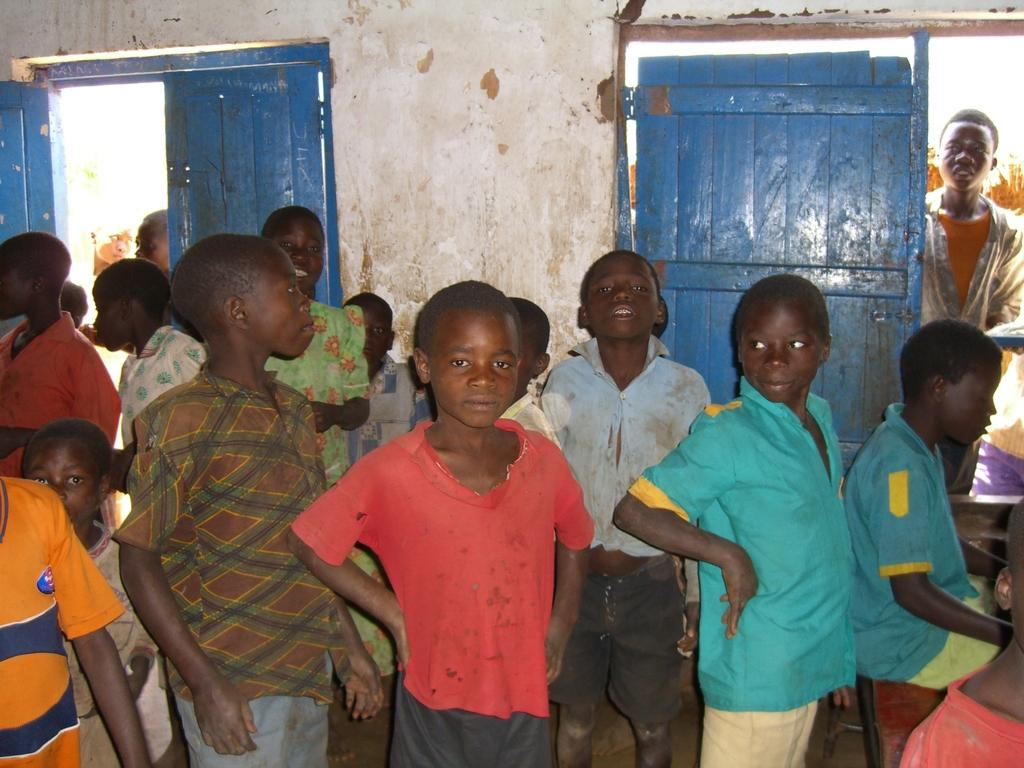What is the main subject of the image? The main subject of the image is a group of children standing together. What type of doors can be seen in the image? There are wooden doors in the image. Can you describe the person standing near the door? There is a person standing near the door, but their appearance or actions are not specified. What is the background of the image composed of? The background of the image includes a wall and a bench. What is the boy in the image doing? There is a boy sitting on the bench in the image. What is the distance between the minister and the children in the image? There is no minister present in the image, so it is not possible to determine the distance between them. 